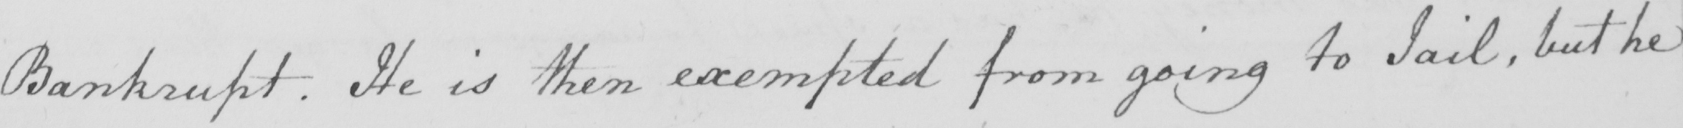What is written in this line of handwriting? Bankrupt . He is then exempted from going to Jail , but he 